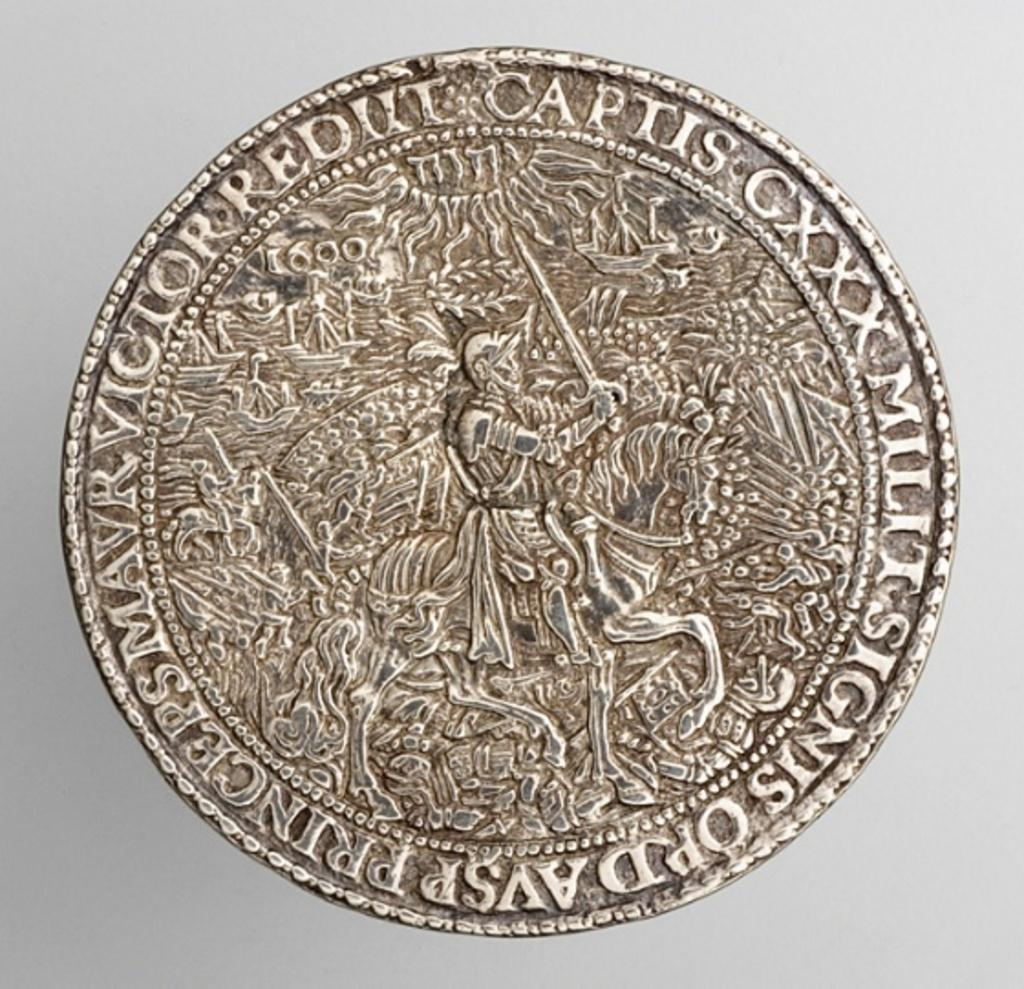<image>
Give a short and clear explanation of the subsequent image. An old coin has the word Captis around the edge. 